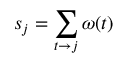<formula> <loc_0><loc_0><loc_500><loc_500>s _ { j } = \sum _ { t \to j } \omega ( t )</formula> 